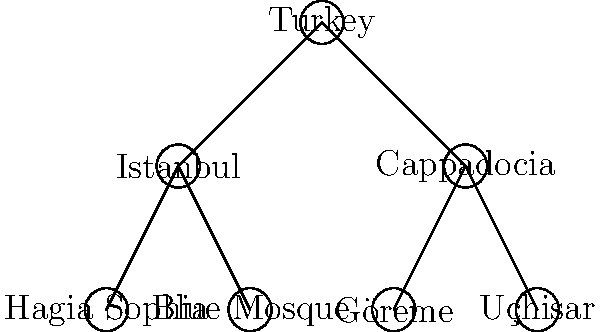Based on the tree diagram representing the hierarchical structure of historical sites in Turkey, what is the total number of leaf nodes (nodes with no children) in the tree? To find the number of leaf nodes in the tree, we need to follow these steps:

1. Identify the root node: Turkey

2. Identify the second level nodes (children of the root):
   - Istanbul
   - Cappadocia

3. Identify the third level nodes (children of the second level):
   - Children of Istanbul:
     a. Hagia Sophia
     b. Blue Mosque
   - Children of Cappadocia:
     a. Göreme
     b. Uçhisar

4. Determine which nodes have no children (leaf nodes):
   - Hagia Sophia
   - Blue Mosque
   - Göreme
   - Uçhisar

5. Count the number of leaf nodes:
   There are 4 leaf nodes in total.

Therefore, the total number of leaf nodes in the tree is 4.
Answer: 4 